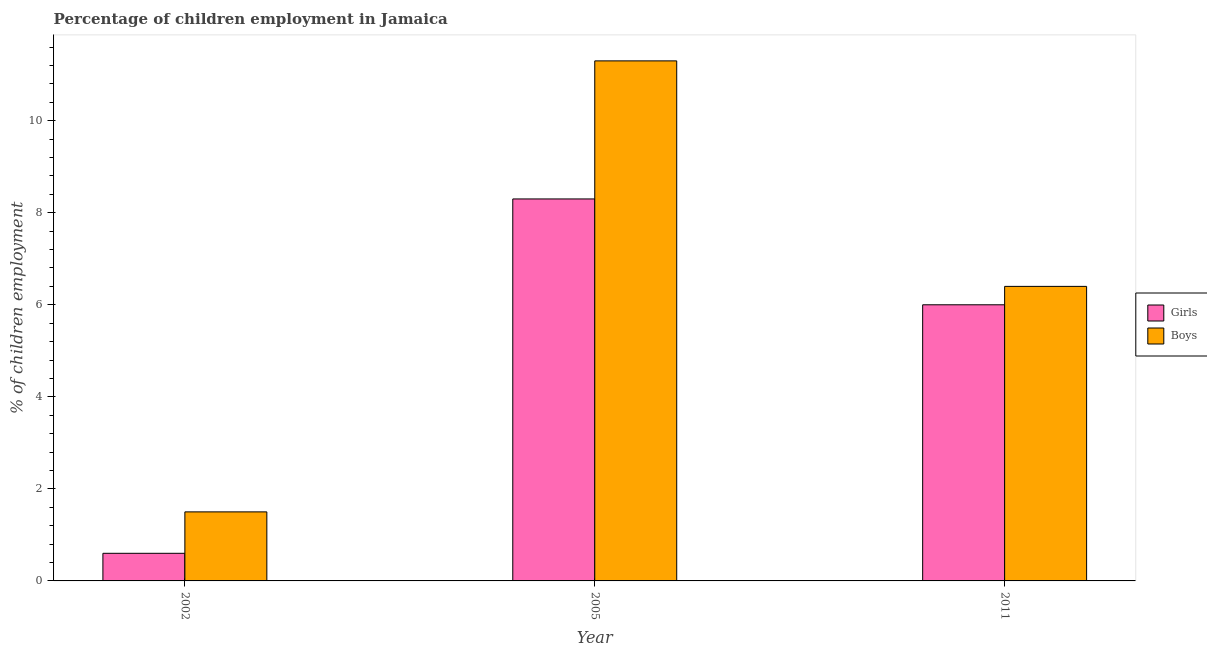How many groups of bars are there?
Your response must be concise. 3. Are the number of bars per tick equal to the number of legend labels?
Provide a short and direct response. Yes. How many bars are there on the 1st tick from the left?
Your response must be concise. 2. What is the label of the 1st group of bars from the left?
Offer a very short reply. 2002. In how many cases, is the number of bars for a given year not equal to the number of legend labels?
Provide a short and direct response. 0. What is the percentage of employed girls in 2005?
Provide a short and direct response. 8.3. Across all years, what is the minimum percentage of employed girls?
Make the answer very short. 0.6. In which year was the percentage of employed girls maximum?
Ensure brevity in your answer.  2005. What is the total percentage of employed boys in the graph?
Provide a short and direct response. 19.2. What is the difference between the percentage of employed girls in 2005 and the percentage of employed boys in 2002?
Your response must be concise. 7.7. What is the average percentage of employed girls per year?
Provide a succinct answer. 4.97. What is the ratio of the percentage of employed girls in 2002 to that in 2011?
Offer a very short reply. 0.1. Is the difference between the percentage of employed boys in 2002 and 2011 greater than the difference between the percentage of employed girls in 2002 and 2011?
Your answer should be compact. No. What is the difference between the highest and the second highest percentage of employed girls?
Ensure brevity in your answer.  2.3. What is the difference between the highest and the lowest percentage of employed girls?
Make the answer very short. 7.7. In how many years, is the percentage of employed boys greater than the average percentage of employed boys taken over all years?
Your answer should be very brief. 1. What does the 2nd bar from the left in 2011 represents?
Keep it short and to the point. Boys. What does the 1st bar from the right in 2011 represents?
Offer a very short reply. Boys. How many years are there in the graph?
Your answer should be very brief. 3. Does the graph contain grids?
Give a very brief answer. No. How are the legend labels stacked?
Your answer should be very brief. Vertical. What is the title of the graph?
Your response must be concise. Percentage of children employment in Jamaica. What is the label or title of the Y-axis?
Your answer should be compact. % of children employment. What is the % of children employment in Boys in 2002?
Offer a very short reply. 1.5. What is the % of children employment of Girls in 2005?
Provide a short and direct response. 8.3. What is the % of children employment of Boys in 2005?
Your response must be concise. 11.3. What is the % of children employment of Girls in 2011?
Your answer should be compact. 6. What is the % of children employment of Boys in 2011?
Ensure brevity in your answer.  6.4. Across all years, what is the maximum % of children employment in Girls?
Provide a succinct answer. 8.3. Across all years, what is the maximum % of children employment in Boys?
Provide a short and direct response. 11.3. Across all years, what is the minimum % of children employment of Girls?
Offer a terse response. 0.6. What is the total % of children employment of Boys in the graph?
Your answer should be compact. 19.2. What is the difference between the % of children employment of Girls in 2002 and that in 2005?
Provide a succinct answer. -7.7. What is the difference between the % of children employment of Boys in 2002 and that in 2005?
Give a very brief answer. -9.8. What is the difference between the % of children employment in Boys in 2002 and that in 2011?
Your response must be concise. -4.9. What is the difference between the % of children employment of Girls in 2005 and that in 2011?
Provide a succinct answer. 2.3. What is the difference between the % of children employment in Girls in 2002 and the % of children employment in Boys in 2005?
Your answer should be compact. -10.7. What is the difference between the % of children employment in Girls in 2005 and the % of children employment in Boys in 2011?
Keep it short and to the point. 1.9. What is the average % of children employment of Girls per year?
Keep it short and to the point. 4.97. In the year 2002, what is the difference between the % of children employment of Girls and % of children employment of Boys?
Make the answer very short. -0.9. What is the ratio of the % of children employment in Girls in 2002 to that in 2005?
Ensure brevity in your answer.  0.07. What is the ratio of the % of children employment in Boys in 2002 to that in 2005?
Your response must be concise. 0.13. What is the ratio of the % of children employment of Girls in 2002 to that in 2011?
Give a very brief answer. 0.1. What is the ratio of the % of children employment in Boys in 2002 to that in 2011?
Offer a terse response. 0.23. What is the ratio of the % of children employment of Girls in 2005 to that in 2011?
Keep it short and to the point. 1.38. What is the ratio of the % of children employment of Boys in 2005 to that in 2011?
Make the answer very short. 1.77. What is the difference between the highest and the second highest % of children employment in Girls?
Offer a very short reply. 2.3. What is the difference between the highest and the lowest % of children employment in Boys?
Provide a short and direct response. 9.8. 